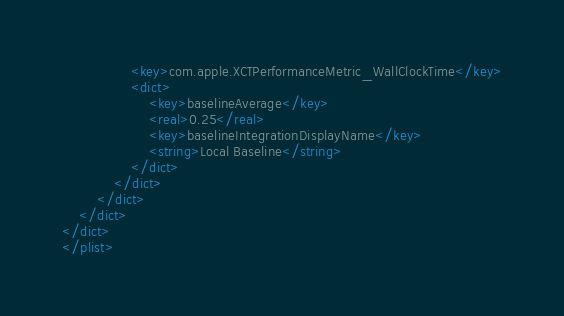<code> <loc_0><loc_0><loc_500><loc_500><_XML_>				<key>com.apple.XCTPerformanceMetric_WallClockTime</key>
				<dict>
					<key>baselineAverage</key>
					<real>0.25</real>
					<key>baselineIntegrationDisplayName</key>
					<string>Local Baseline</string>
				</dict>
			</dict>
		</dict>
	</dict>
</dict>
</plist>
</code> 